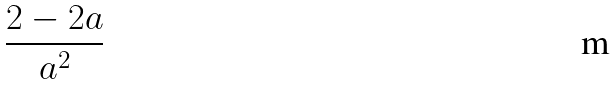<formula> <loc_0><loc_0><loc_500><loc_500>\frac { 2 - 2 a } { a ^ { 2 } }</formula> 